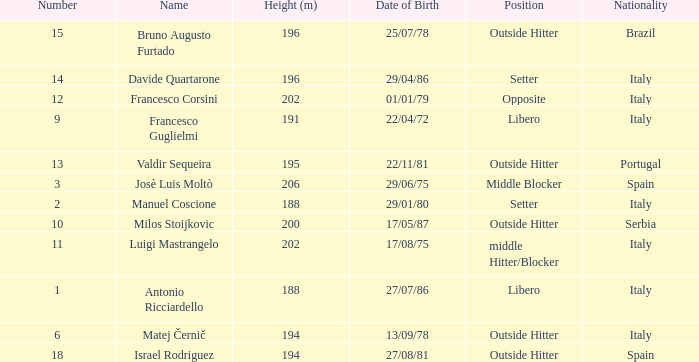Name the nationality for francesco guglielmi Italy. 